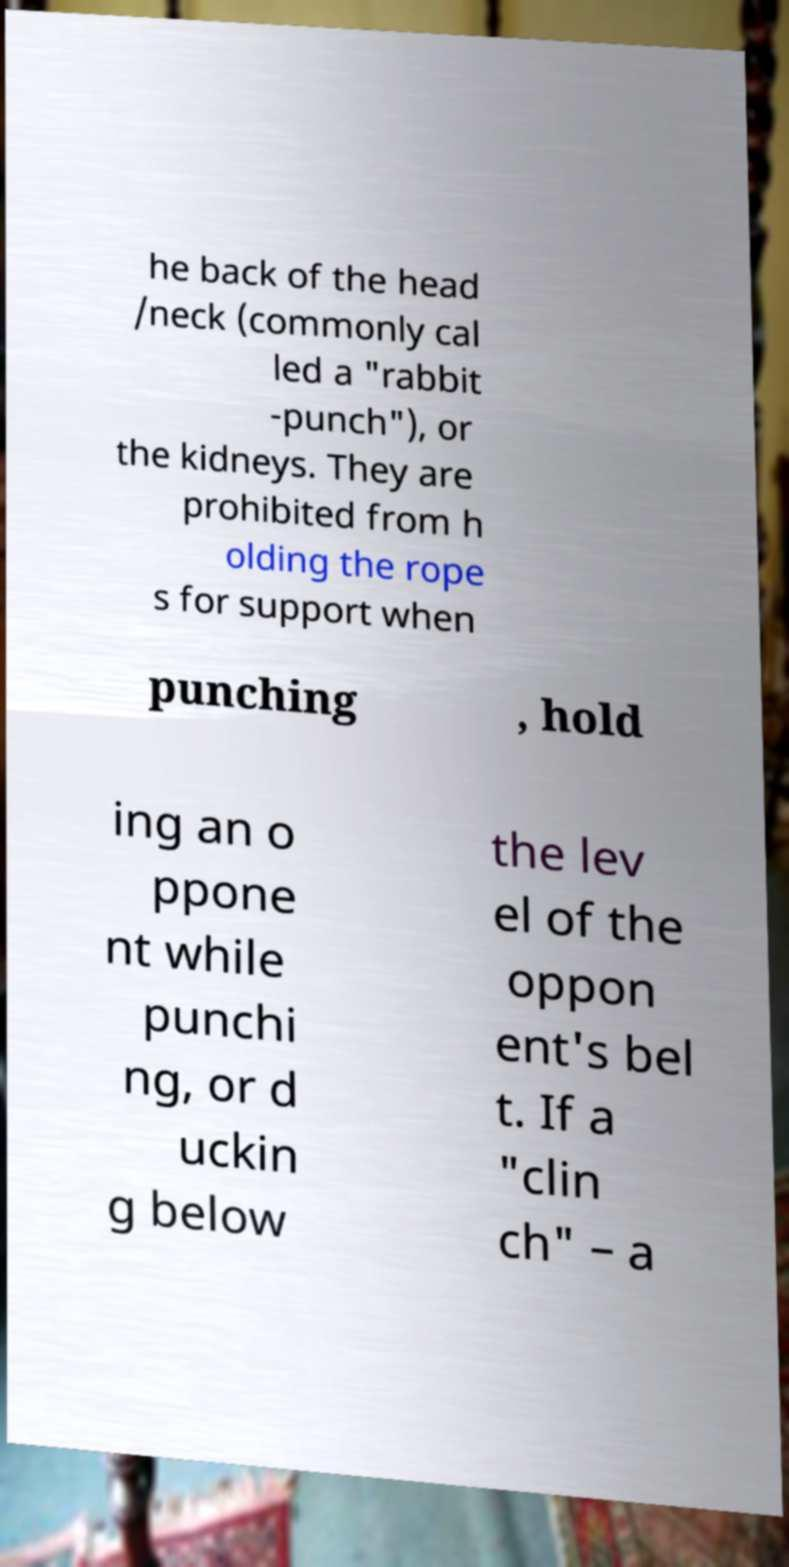I need the written content from this picture converted into text. Can you do that? he back of the head /neck (commonly cal led a "rabbit -punch"), or the kidneys. They are prohibited from h olding the rope s for support when punching , hold ing an o ppone nt while punchi ng, or d uckin g below the lev el of the oppon ent's bel t. If a "clin ch" – a 